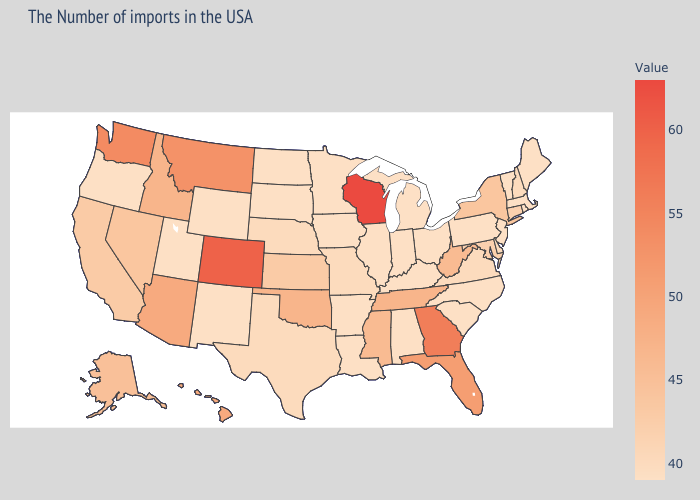Which states have the highest value in the USA?
Keep it brief. Wisconsin. Which states have the highest value in the USA?
Be succinct. Wisconsin. Is the legend a continuous bar?
Give a very brief answer. Yes. Does the map have missing data?
Quick response, please. No. Among the states that border Alabama , does Tennessee have the lowest value?
Be succinct. No. Does the map have missing data?
Concise answer only. No. 